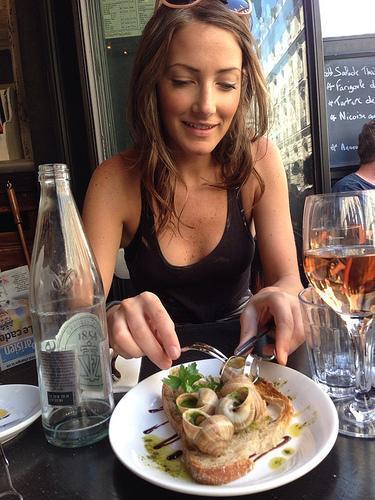How many glasses are there?
Give a very brief answer. 2. 